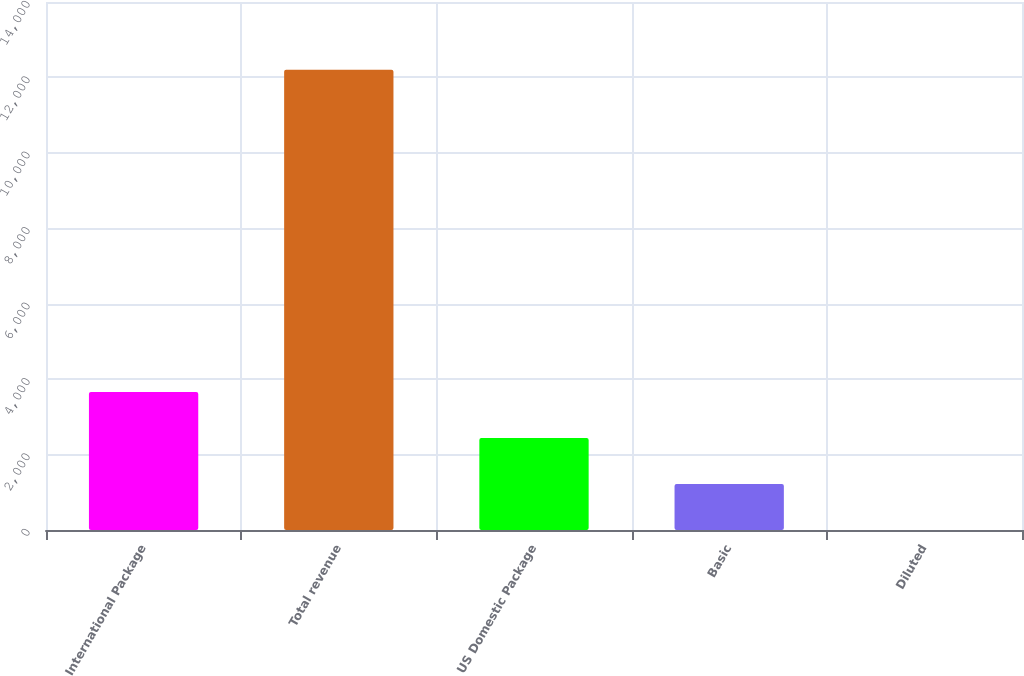<chart> <loc_0><loc_0><loc_500><loc_500><bar_chart><fcel>International Package<fcel>Total revenue<fcel>US Domestic Package<fcel>Basic<fcel>Diluted<nl><fcel>3661.8<fcel>12204<fcel>2441.48<fcel>1221.16<fcel>0.84<nl></chart> 